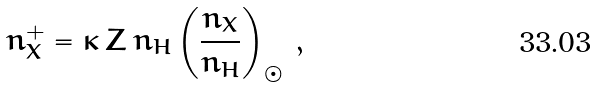<formula> <loc_0><loc_0><loc_500><loc_500>n _ { X } ^ { + } = \kappa \, Z \, n _ { H } \left ( \frac { n _ { X } } { n _ { H } } \right ) _ { \odot } \, ,</formula> 